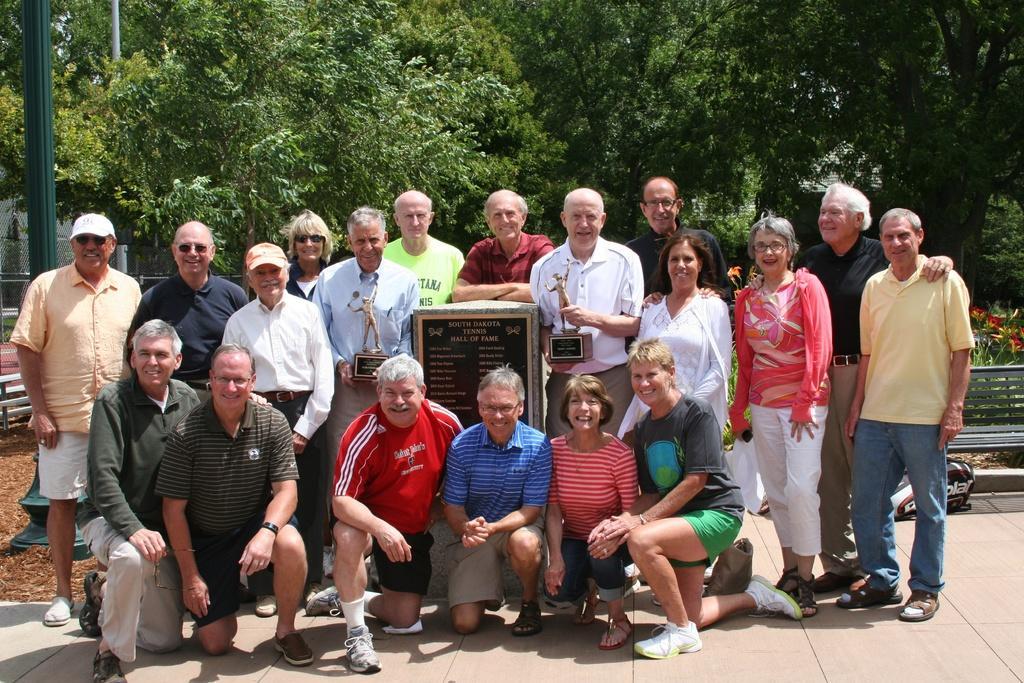Can you describe this image briefly? In this image in the center a group of people some of them are standing and some of them are sitting on their knees, and they are smiling and in the center there is one board. On the board there is some text and two persons are holding shields, in the background there are some trees, bench, pole and some objects. At the bottom there is a walkway. 